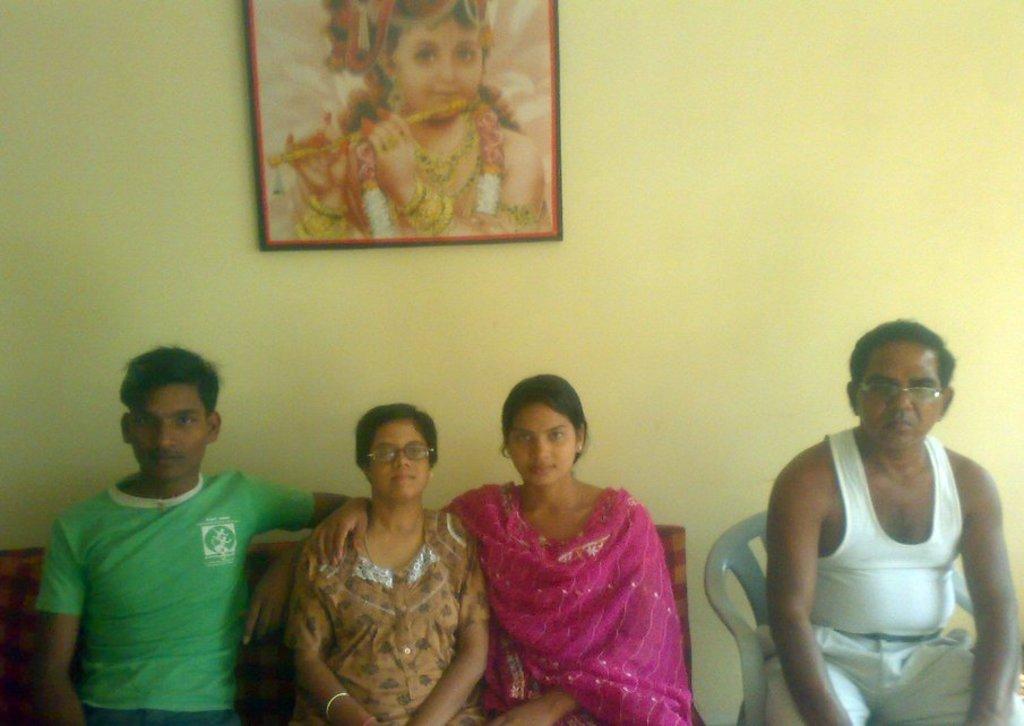Could you give a brief overview of what you see in this image? On the left side three persons are sitting on a sofa. On the right side there is a man wearing specs is sitting on a chair. In the back there is a wall with photo frame. 